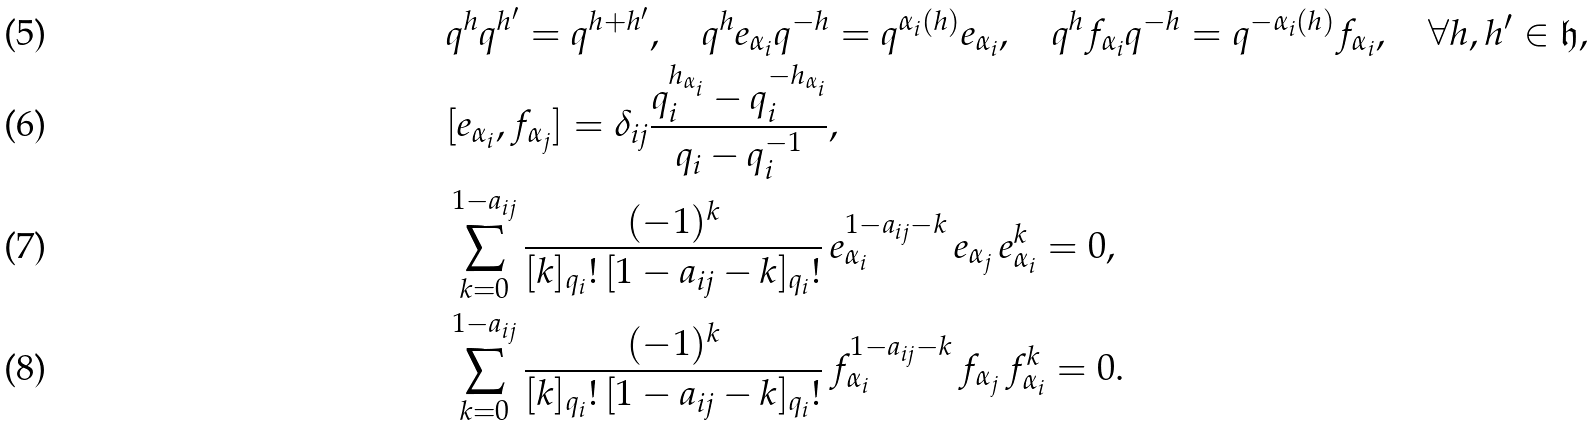<formula> <loc_0><loc_0><loc_500><loc_500>& q ^ { h } q ^ { h ^ { \prime } } = q ^ { h + h ^ { \prime } } , \quad q ^ { h } e _ { \alpha _ { i } } q ^ { - h } = q ^ { \alpha _ { i } ( h ) } e _ { \alpha _ { i } } , \quad q ^ { h } f _ { \alpha _ { i } } q ^ { - h } = q ^ { - \alpha _ { i } ( h ) } f _ { \alpha _ { i } } , \quad \forall h , h ^ { \prime } \in \mathfrak { h } , \\ & [ e _ { \alpha _ { i } } , f _ { \alpha _ { j } } ] = \delta _ { i j } \frac { q _ { i } ^ { h _ { \alpha _ { i } } } - q _ { i } ^ { - h _ { \alpha _ { i } } } } { q _ { i } - q _ { i } ^ { - 1 } } , \\ & \sum _ { k = 0 } ^ { 1 - a _ { i j } } \frac { ( - 1 ) ^ { k } } { [ k ] _ { q _ { i } } ! \, [ 1 - a _ { i j } - k ] _ { q _ { i } } ! } \, e _ { \alpha _ { i } } ^ { 1 - a _ { i j } - k } \, e _ { \alpha _ { j } } \, e _ { \alpha _ { i } } ^ { k } = 0 , \\ & \sum _ { k = 0 } ^ { 1 - a _ { i j } } \frac { ( - 1 ) ^ { k } } { [ k ] _ { q _ { i } } ! \, [ 1 - a _ { i j } - k ] _ { q _ { i } } ! } \, f _ { \alpha _ { i } } ^ { 1 - a _ { i j } - k } \, f _ { \alpha _ { j } } \, f _ { \alpha _ { i } } ^ { k } = 0 .</formula> 